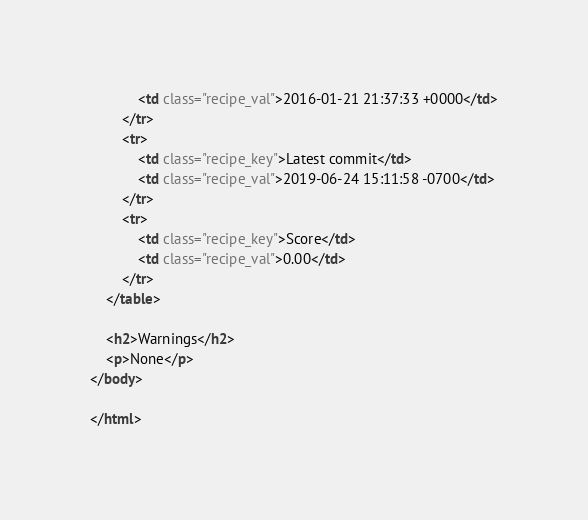Convert code to text. <code><loc_0><loc_0><loc_500><loc_500><_HTML_>            <td class="recipe_val">2016-01-21 21:37:33 +0000</td>
        </tr>
        <tr>
            <td class="recipe_key">Latest commit</td>
            <td class="recipe_val">2019-06-24 15:11:58 -0700</td>
        </tr>
        <tr>
            <td class="recipe_key">Score</td>
            <td class="recipe_val">0.00</td>
        </tr>
    </table>

    <h2>Warnings</h2>
    <p>None</p>
</body>

</html>
</code> 